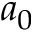<formula> <loc_0><loc_0><loc_500><loc_500>a _ { 0 }</formula> 